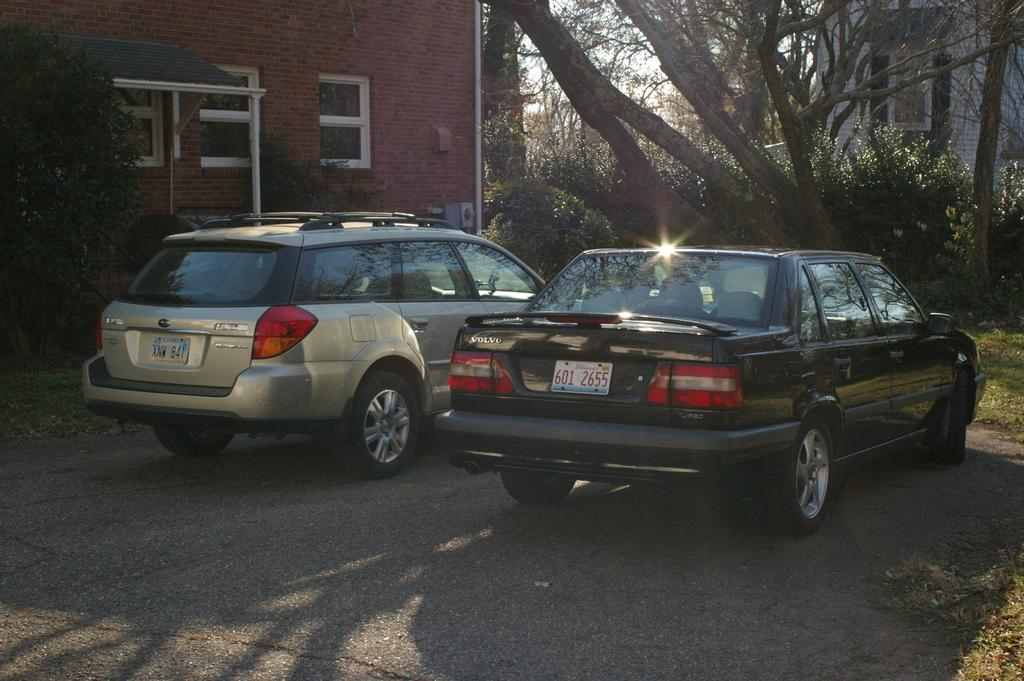How many vehicles can be seen on the road in the image? There are two vehicles on the road in the image. What other elements are present in the image besides the vehicles? There are plants, buildings, windows, trees, grass, and the sky visible in the image. What type of vase can be seen on the low property in the image? There is no vase or property present in the image. 